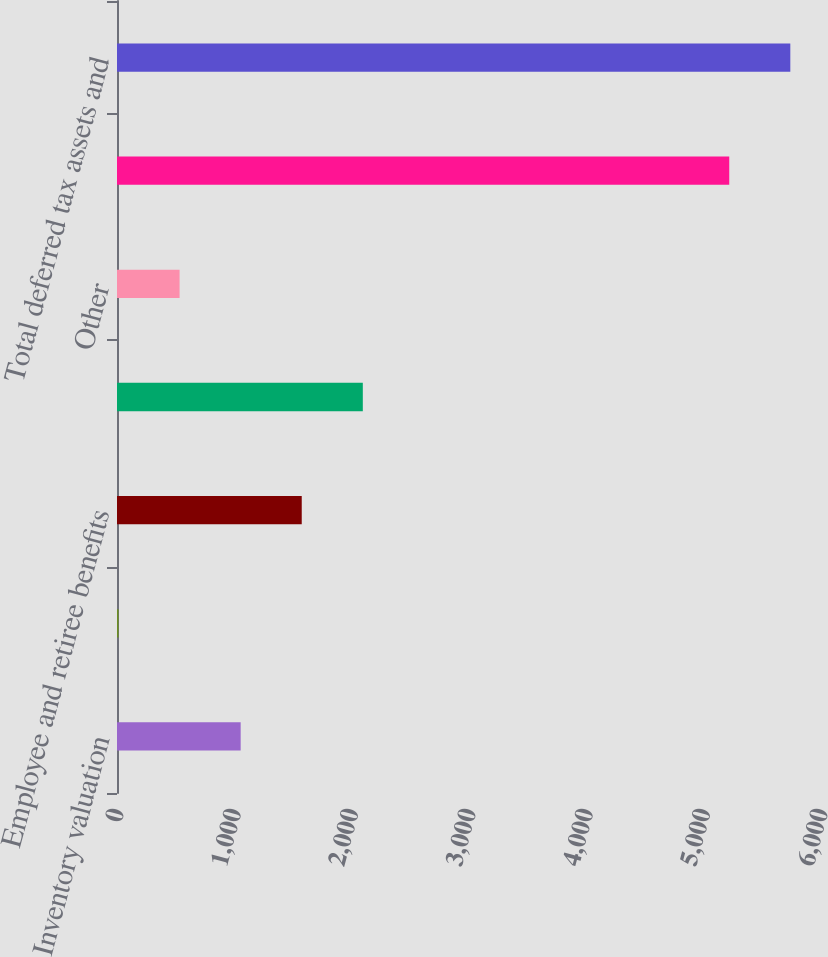Convert chart. <chart><loc_0><loc_0><loc_500><loc_500><bar_chart><fcel>Inventory valuation<fcel>Fixed assets<fcel>Employee and retiree benefits<fcel>Purchased intangible assets<fcel>Other<fcel>Gross deferred tax assets and<fcel>Total deferred tax assets and<nl><fcel>1054<fcel>13<fcel>1574.5<fcel>2095<fcel>533.5<fcel>5218<fcel>5738.5<nl></chart> 